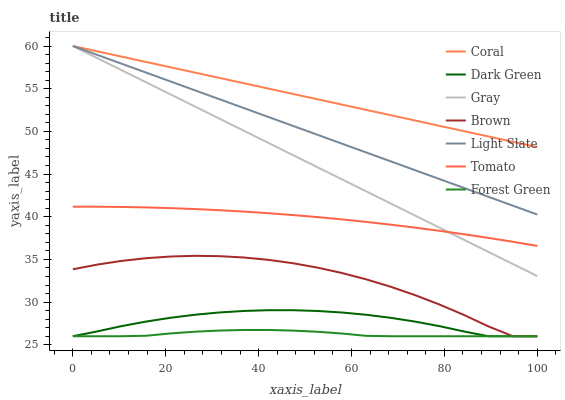Does Forest Green have the minimum area under the curve?
Answer yes or no. Yes. Does Coral have the maximum area under the curve?
Answer yes or no. Yes. Does Gray have the minimum area under the curve?
Answer yes or no. No. Does Gray have the maximum area under the curve?
Answer yes or no. No. Is Coral the smoothest?
Answer yes or no. Yes. Is Brown the roughest?
Answer yes or no. Yes. Is Gray the smoothest?
Answer yes or no. No. Is Gray the roughest?
Answer yes or no. No. Does Brown have the lowest value?
Answer yes or no. Yes. Does Gray have the lowest value?
Answer yes or no. No. Does Coral have the highest value?
Answer yes or no. Yes. Does Brown have the highest value?
Answer yes or no. No. Is Brown less than Tomato?
Answer yes or no. Yes. Is Gray greater than Brown?
Answer yes or no. Yes. Does Gray intersect Coral?
Answer yes or no. Yes. Is Gray less than Coral?
Answer yes or no. No. Is Gray greater than Coral?
Answer yes or no. No. Does Brown intersect Tomato?
Answer yes or no. No. 